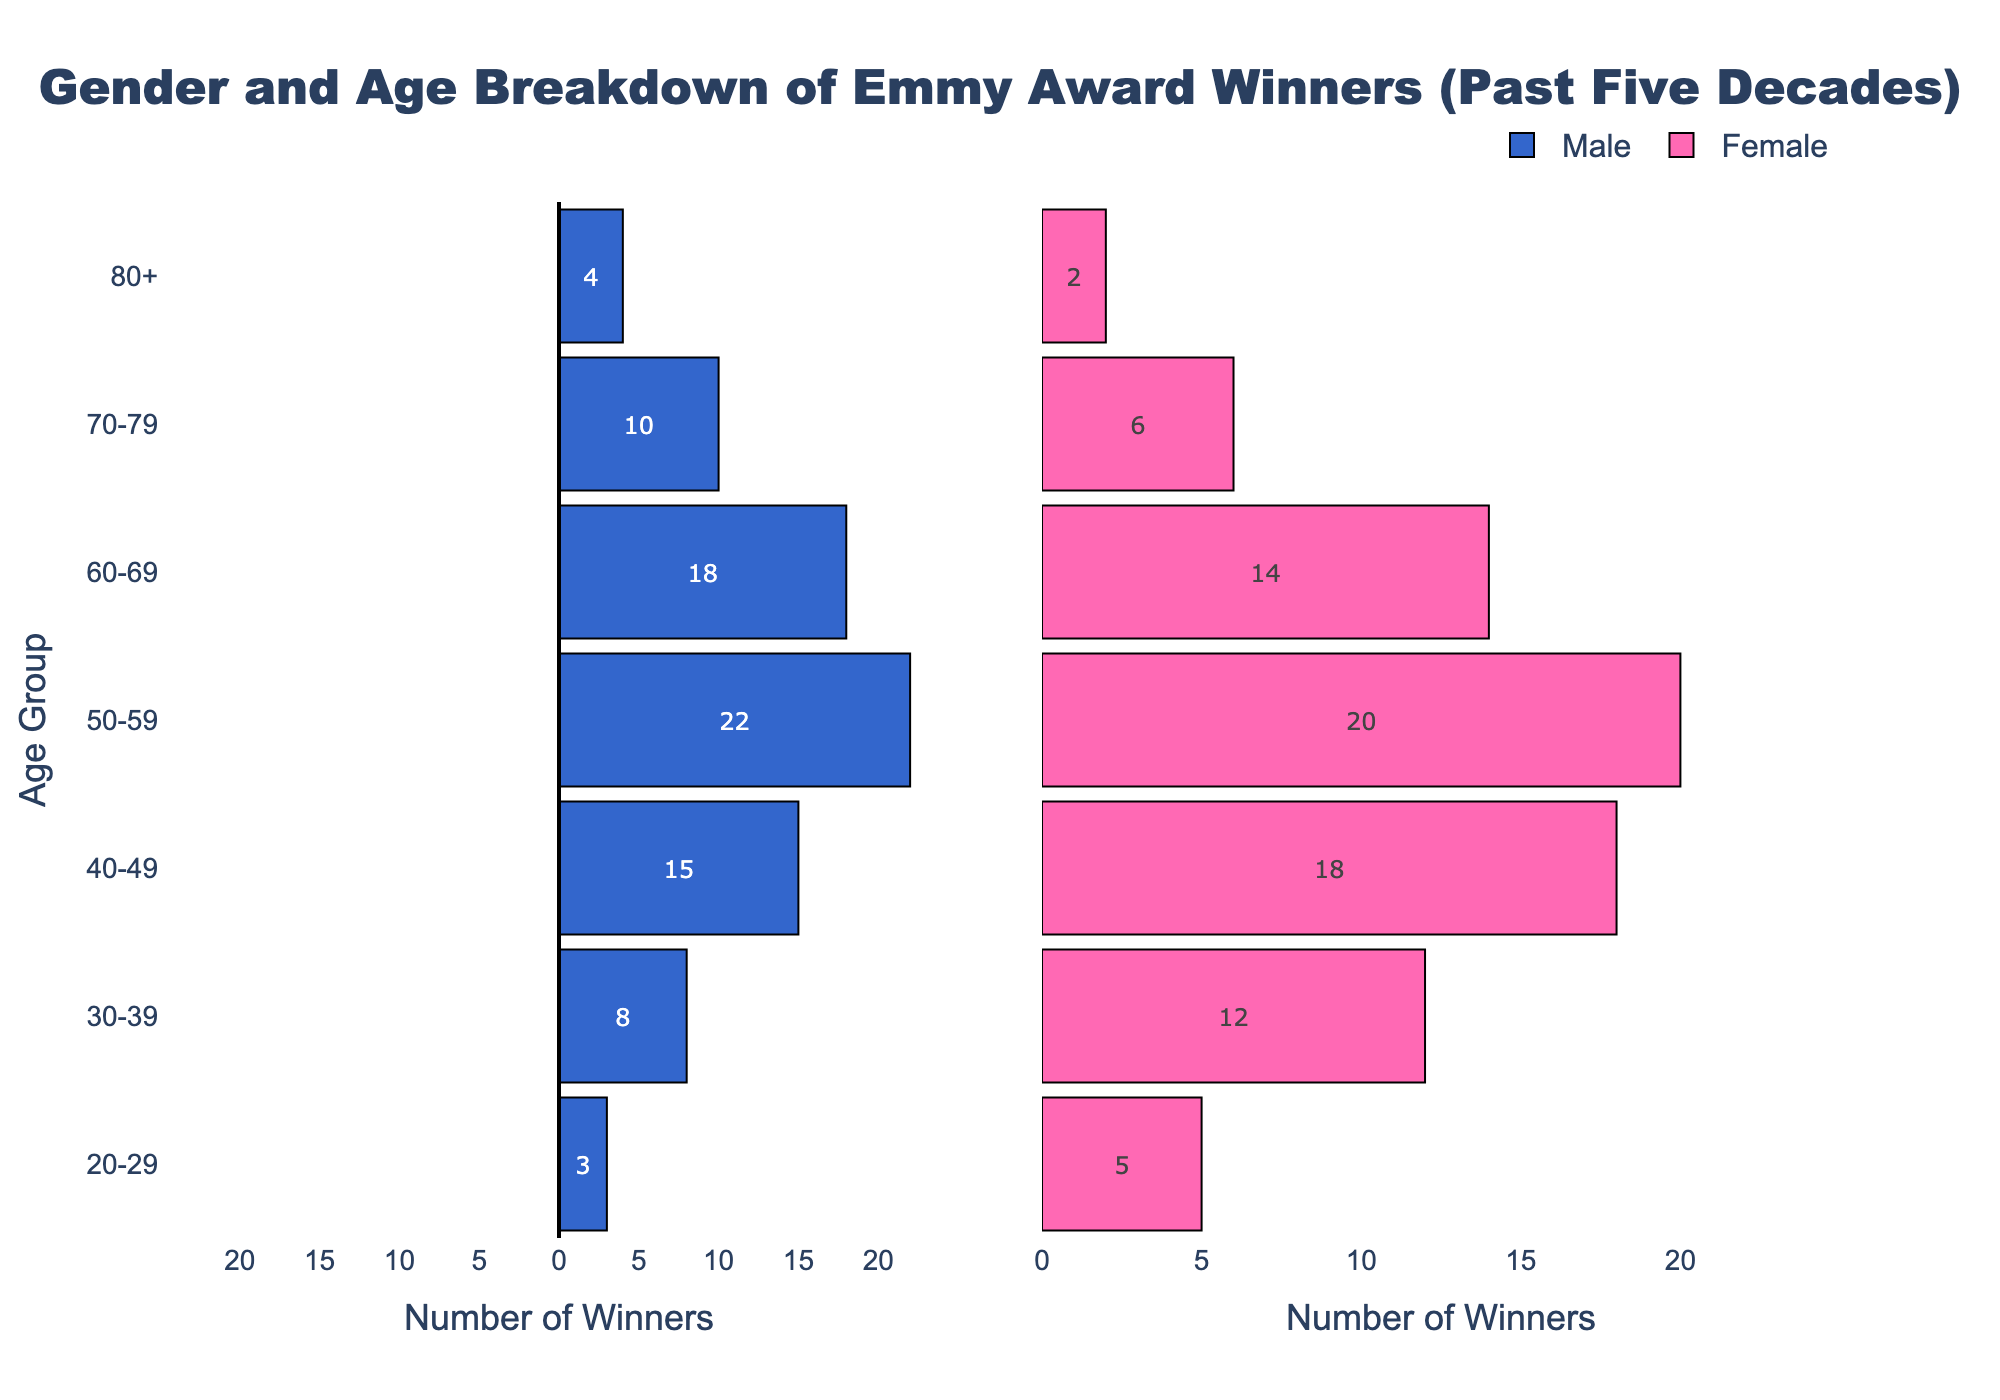What is the age group with the highest number of female Emmy Award winners? Observing the plot, you can see the tallest pink bar in the female section corresponds to the 30-39 age group, indicating the highest number of female winners.
Answer: 30-39 What is the age group with the lowest number of male Emmy Award winners? Looking at the left side of the pyramid, the smallest blue bar belongs to the 20-29 age group, indicating the lowest number of male winners.
Answer: 20-29 How do the number of male winners in the 50-59 age group compare to female winners in the same age group? In the 50-59 age group, the male bar extends to -22, while the female bar extends to 20. This indicates there are more male winners in this group.
Answer: More male winners In which age group is the gender disparity (difference between male and female winners) the largest? By calculating the absolute differences for each age group, the largest disparity is found in the 50-59 age group, with a difference of 22 (male) + 20 (female) = 42 winners.
Answer: 50-59 How many female Emmy Award winners are there in the 70-79 age group? Refer to the pink bar corresponding to the 70-79 age group; it extends to 6.
Answer: 6 What is the total number of Emmy winners in the 40-49 age group? Adding the absolute values of male and female winners in the 40-49 age group:
Answer: 33 Which gender has a higher number of winners in the 60-69 age group? In the 60-69 age group, the pink bar (female) extends to 14, and the blue bar (male) extends to -18. Since 18 is greater, males dominate this age group.
Answer: Male What trends can be observed in the number of winners in the youngest and oldest age groups? In both the 20-29 and 80+ age groups, the number of winners is relatively lower for both genders compared to middle age groups, indicating fewer winners in these extremes.
Answer: Fewer winners in youngest and oldest groups 